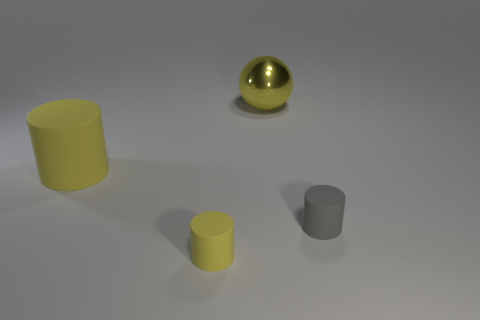Add 4 yellow metal things. How many objects exist? 8 Subtract all cylinders. How many objects are left? 1 Subtract all blocks. Subtract all shiny balls. How many objects are left? 3 Add 1 large yellow rubber cylinders. How many large yellow rubber cylinders are left? 2 Add 1 small gray rubber cylinders. How many small gray rubber cylinders exist? 2 Subtract 0 blue balls. How many objects are left? 4 